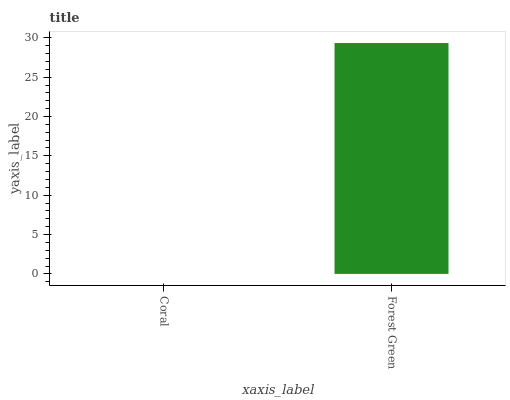Is Coral the minimum?
Answer yes or no. Yes. Is Forest Green the maximum?
Answer yes or no. Yes. Is Forest Green the minimum?
Answer yes or no. No. Is Forest Green greater than Coral?
Answer yes or no. Yes. Is Coral less than Forest Green?
Answer yes or no. Yes. Is Coral greater than Forest Green?
Answer yes or no. No. Is Forest Green less than Coral?
Answer yes or no. No. Is Forest Green the high median?
Answer yes or no. Yes. Is Coral the low median?
Answer yes or no. Yes. Is Coral the high median?
Answer yes or no. No. Is Forest Green the low median?
Answer yes or no. No. 